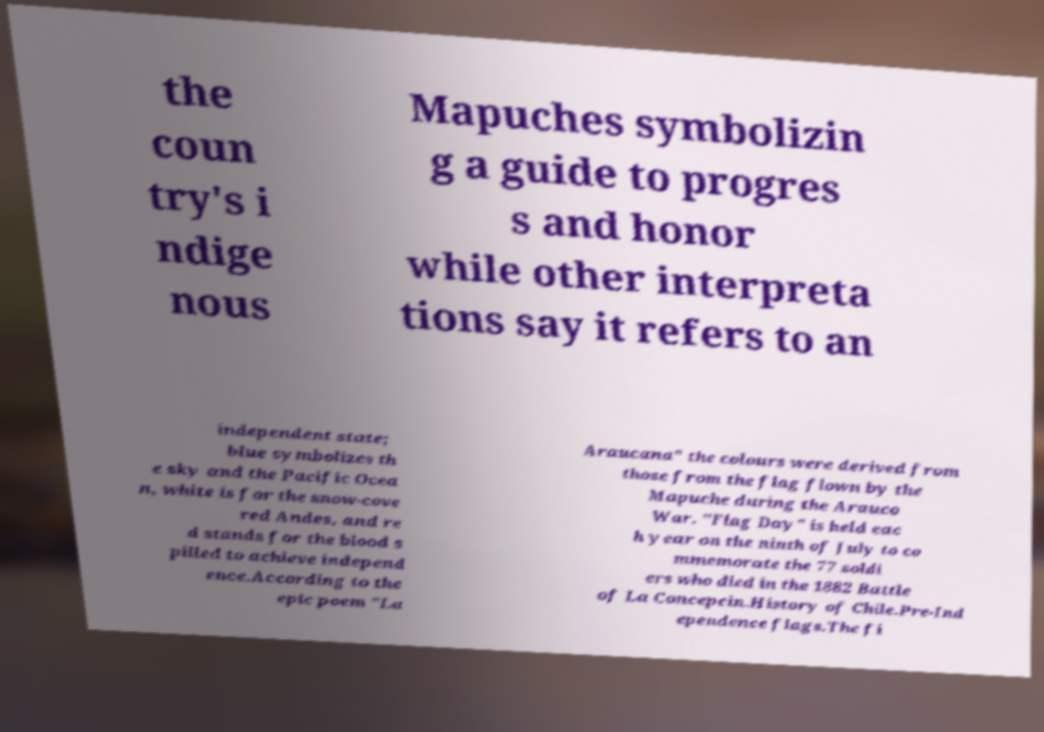Can you accurately transcribe the text from the provided image for me? the coun try's i ndige nous Mapuches symbolizin g a guide to progres s and honor while other interpreta tions say it refers to an independent state; blue symbolizes th e sky and the Pacific Ocea n, white is for the snow-cove red Andes, and re d stands for the blood s pilled to achieve independ ence.According to the epic poem "La Araucana" the colours were derived from those from the flag flown by the Mapuche during the Arauco War. "Flag Day" is held eac h year on the ninth of July to co mmemorate the 77 soldi ers who died in the 1882 Battle of La Concepcin.History of Chile.Pre-Ind ependence flags.The fi 